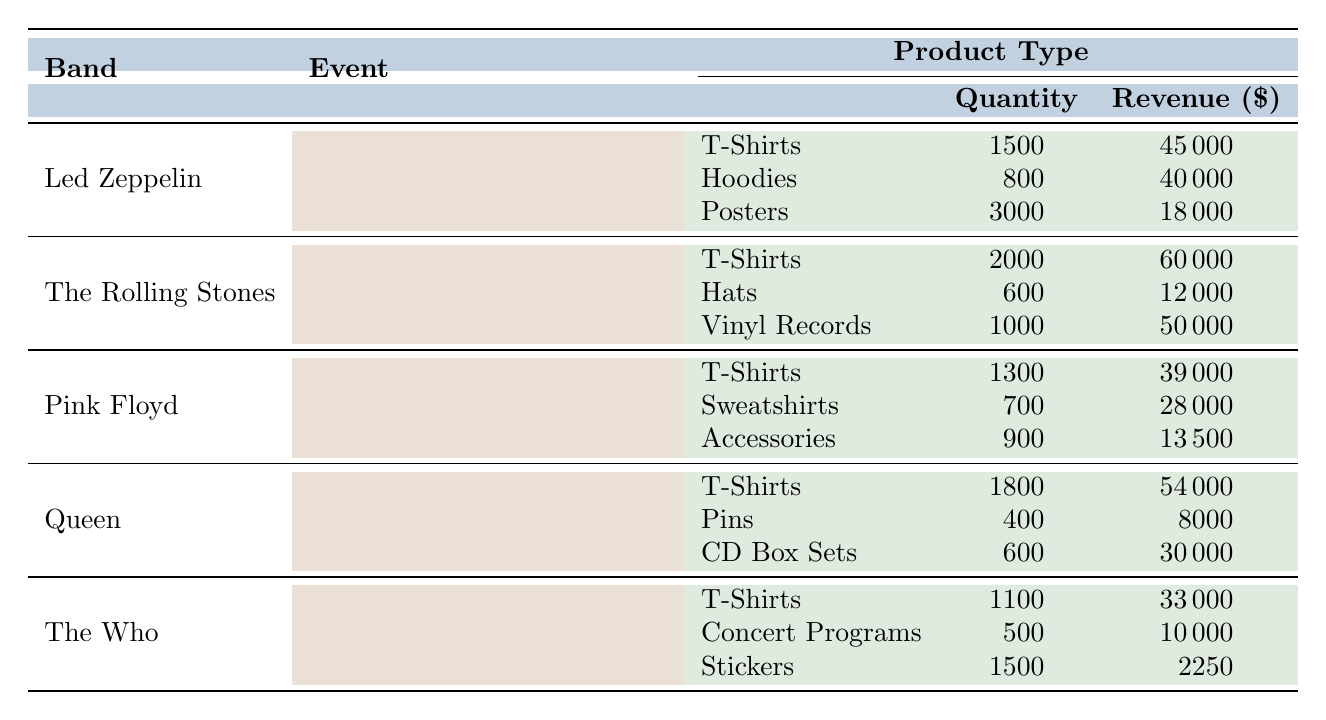What is the total revenue generated by Led Zeppelin from merchandise sales? Led Zeppelin has three products with revenues of $45,000 from T-Shirts, $40,000 from Hoodies, and $18,000 from Posters. Adding these amounts gives a total revenue of $45,000 + $40,000 + $18,000 = $103,000.
Answer: $103,000 Which classic rock band sold the most T-Shirts? The Rolling Stones sold 2,000 T-Shirts, which is the highest quantity compared to Led Zeppelin (1,500), Pink Floyd (1,300), Queen (1,800), and The Who (1,100).
Answer: The Rolling Stones What is the total quantity of merchandise sold by Queen? Queen sold T-Shirts (1,800), Pins (400), and CD Box Sets (600). Summing these quantities gives 1,800 + 400 + 600 = 2,800 total merchandise sold.
Answer: 2,800 Did Pink Floyd generate more revenue from T-Shirts than from Sweatshirts and Accessories combined? Pink Floyd earned $39,000 from T-Shirts, $28,000 from Sweatshirts, and $13,500 from Accessories. The combined revenue from Sweatshirts and Accessories is $28,000 + $13,500 = $41,500, which is higher than $39,000 from T-Shirts. Therefore, the statement is true.
Answer: Yes What was the average revenue generated per product type for The Who? The Who sold T-Shirts ($33,000), Concert Programs ($10,000), and Stickers ($2,250). First, add these revenues: $33,000 + $10,000 + $2,250 = $45,250. Then, divide by the number of products (3) for the average: $45,250 / 3 = $15,083.33.
Answer: $15,083.33 Which event generated the highest total revenue across all bands? The total revenues are: Led Zeppelin ($103,000), The Rolling Stones ($116,000), Pink Floyd ($83,500), Queen ($88,000), and The Who ($45,250). The Rolling Stones' event generated the highest revenue of $116,000.
Answer: Summer Stadium Shows 2023 What product type had the lowest total revenue across all bands? To find the lowest revenue product type, we must sum the revenues: Hoodies ($40,000), Hats ($12,000), Sweatshirts ($28,000), Pins ($8,000), and Stickers ($2,250). The lowest total is for Stickers at $2,250.
Answer: Stickers If we only consider T-shirt sales, which band earned the most? The revenues from T-shirts are: Led Zeppelin ($45,000), The Rolling Stones ($60,000), Pink Floyd ($39,000), Queen ($54,000), and The Who ($33,000). The Rolling Stones had the highest revenue from T-shirts at $60,000.
Answer: The Rolling Stones 